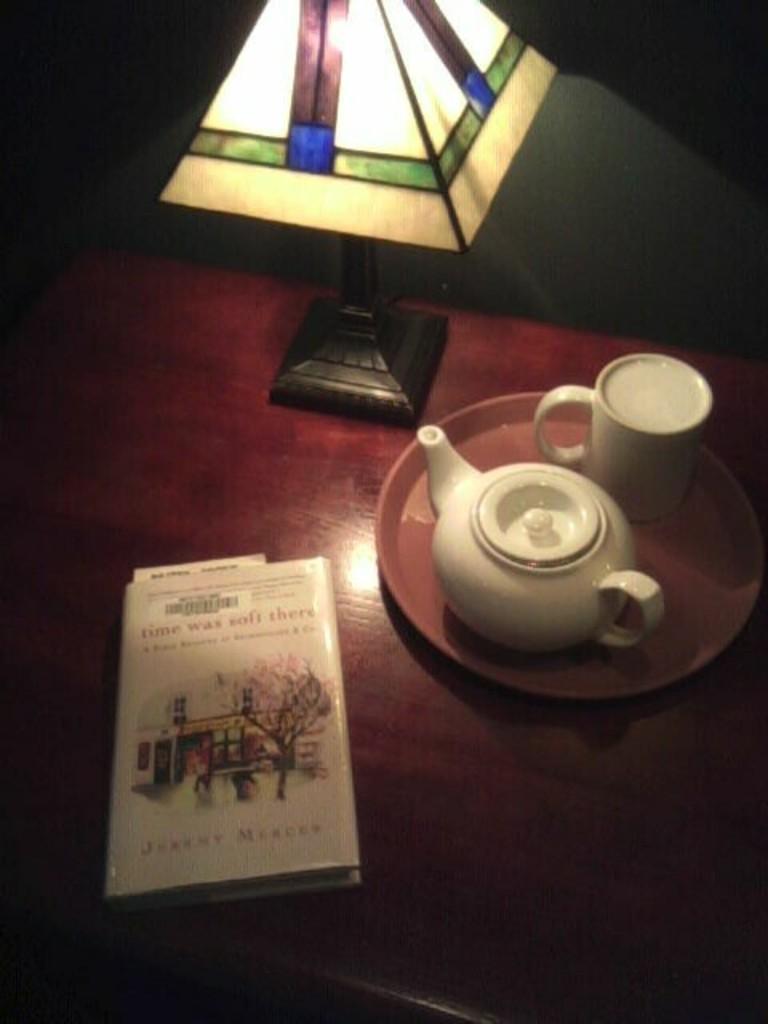How would you summarize this image in a sentence or two? In the image there is a cup, jar, plate, book and a lamp which are placed on the table. in the background there is a wall. 